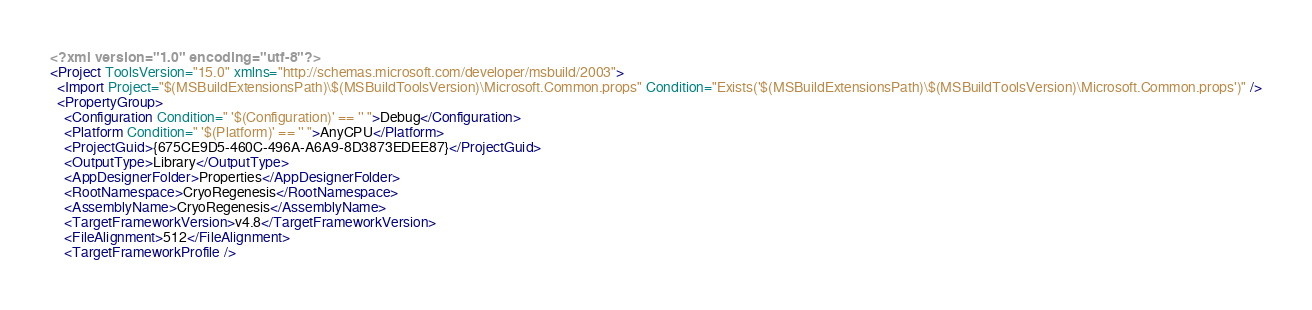Convert code to text. <code><loc_0><loc_0><loc_500><loc_500><_XML_><?xml version="1.0" encoding="utf-8"?>
<Project ToolsVersion="15.0" xmlns="http://schemas.microsoft.com/developer/msbuild/2003">
  <Import Project="$(MSBuildExtensionsPath)\$(MSBuildToolsVersion)\Microsoft.Common.props" Condition="Exists('$(MSBuildExtensionsPath)\$(MSBuildToolsVersion)\Microsoft.Common.props')" />
  <PropertyGroup>
    <Configuration Condition=" '$(Configuration)' == '' ">Debug</Configuration>
    <Platform Condition=" '$(Platform)' == '' ">AnyCPU</Platform>
    <ProjectGuid>{675CE9D5-460C-496A-A6A9-8D3873EDEE87}</ProjectGuid>
    <OutputType>Library</OutputType>
    <AppDesignerFolder>Properties</AppDesignerFolder>
    <RootNamespace>CryoRegenesis</RootNamespace>
    <AssemblyName>CryoRegenesis</AssemblyName>
    <TargetFrameworkVersion>v4.8</TargetFrameworkVersion>
    <FileAlignment>512</FileAlignment>
    <TargetFrameworkProfile /></code> 